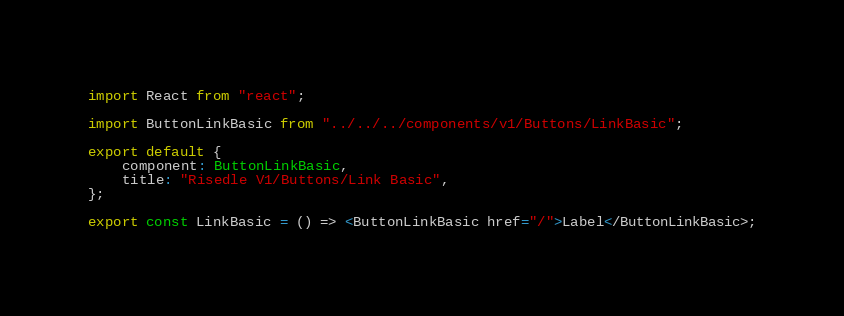Convert code to text. <code><loc_0><loc_0><loc_500><loc_500><_TypeScript_>import React from "react";

import ButtonLinkBasic from "../../../components/v1/Buttons/LinkBasic";

export default {
    component: ButtonLinkBasic,
    title: "Risedle V1/Buttons/Link Basic",
};

export const LinkBasic = () => <ButtonLinkBasic href="/">Label</ButtonLinkBasic>;
</code> 